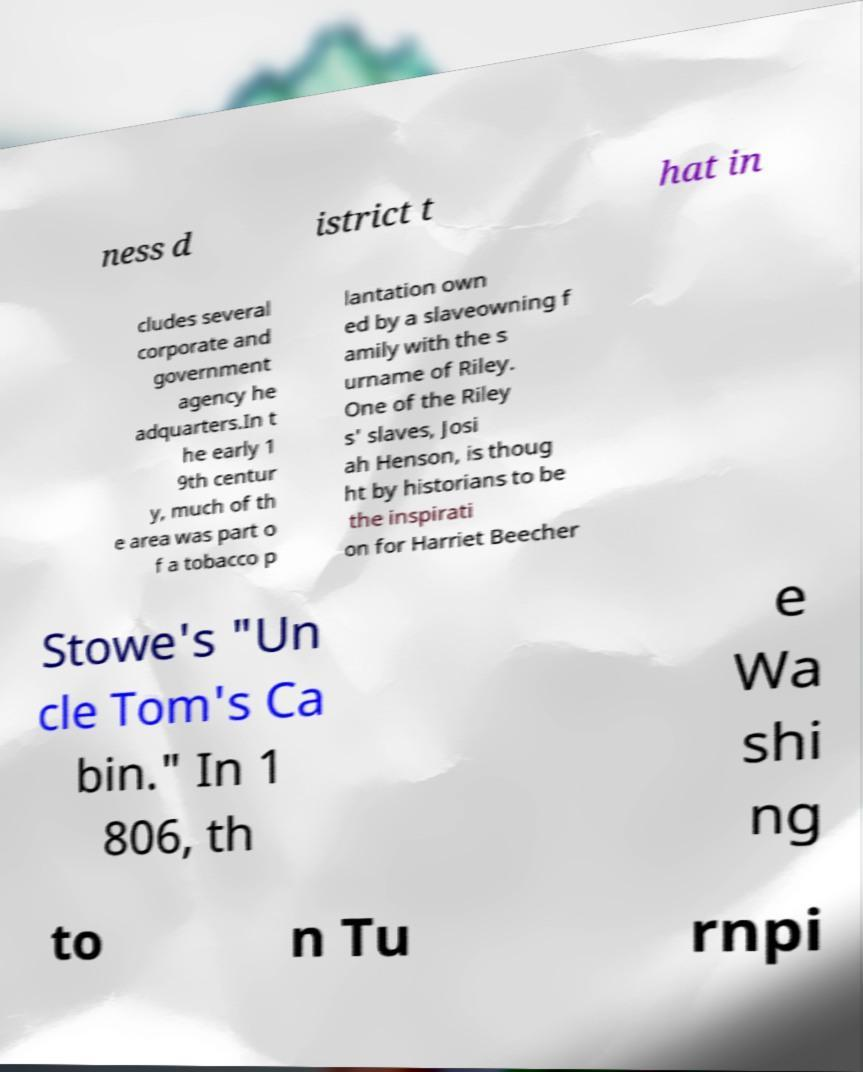Could you extract and type out the text from this image? ness d istrict t hat in cludes several corporate and government agency he adquarters.In t he early 1 9th centur y, much of th e area was part o f a tobacco p lantation own ed by a slaveowning f amily with the s urname of Riley. One of the Riley s' slaves, Josi ah Henson, is thoug ht by historians to be the inspirati on for Harriet Beecher Stowe's "Un cle Tom's Ca bin." In 1 806, th e Wa shi ng to n Tu rnpi 